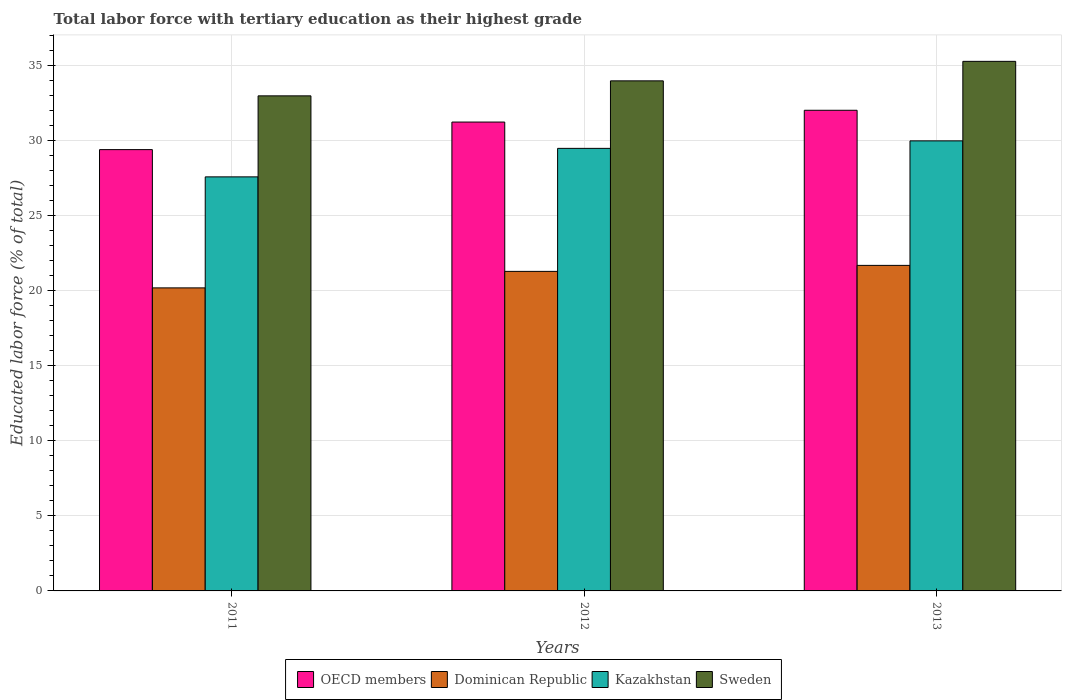Are the number of bars per tick equal to the number of legend labels?
Your answer should be compact. Yes. Are the number of bars on each tick of the X-axis equal?
Offer a very short reply. Yes. How many bars are there on the 2nd tick from the left?
Give a very brief answer. 4. What is the percentage of male labor force with tertiary education in Dominican Republic in 2011?
Offer a very short reply. 20.2. Across all years, what is the maximum percentage of male labor force with tertiary education in Kazakhstan?
Offer a terse response. 30. Across all years, what is the minimum percentage of male labor force with tertiary education in OECD members?
Keep it short and to the point. 29.42. What is the total percentage of male labor force with tertiary education in Dominican Republic in the graph?
Your response must be concise. 63.2. What is the difference between the percentage of male labor force with tertiary education in OECD members in 2011 and the percentage of male labor force with tertiary education in Sweden in 2013?
Your answer should be very brief. -5.88. What is the average percentage of male labor force with tertiary education in Kazakhstan per year?
Give a very brief answer. 29.03. In the year 2013, what is the difference between the percentage of male labor force with tertiary education in Kazakhstan and percentage of male labor force with tertiary education in OECD members?
Your response must be concise. -2.04. What is the ratio of the percentage of male labor force with tertiary education in Dominican Republic in 2012 to that in 2013?
Ensure brevity in your answer.  0.98. Is the percentage of male labor force with tertiary education in Dominican Republic in 2011 less than that in 2013?
Keep it short and to the point. Yes. What is the difference between the highest and the second highest percentage of male labor force with tertiary education in Dominican Republic?
Make the answer very short. 0.4. In how many years, is the percentage of male labor force with tertiary education in Dominican Republic greater than the average percentage of male labor force with tertiary education in Dominican Republic taken over all years?
Your answer should be compact. 2. Is it the case that in every year, the sum of the percentage of male labor force with tertiary education in OECD members and percentage of male labor force with tertiary education in Kazakhstan is greater than the sum of percentage of male labor force with tertiary education in Sweden and percentage of male labor force with tertiary education in Dominican Republic?
Give a very brief answer. No. What does the 4th bar from the left in 2011 represents?
Ensure brevity in your answer.  Sweden. Is it the case that in every year, the sum of the percentage of male labor force with tertiary education in Dominican Republic and percentage of male labor force with tertiary education in Sweden is greater than the percentage of male labor force with tertiary education in Kazakhstan?
Make the answer very short. Yes. How many years are there in the graph?
Offer a very short reply. 3. Where does the legend appear in the graph?
Ensure brevity in your answer.  Bottom center. How many legend labels are there?
Keep it short and to the point. 4. What is the title of the graph?
Make the answer very short. Total labor force with tertiary education as their highest grade. What is the label or title of the Y-axis?
Offer a terse response. Educated labor force (% of total). What is the Educated labor force (% of total) in OECD members in 2011?
Keep it short and to the point. 29.42. What is the Educated labor force (% of total) of Dominican Republic in 2011?
Your response must be concise. 20.2. What is the Educated labor force (% of total) of Kazakhstan in 2011?
Your answer should be very brief. 27.6. What is the Educated labor force (% of total) in OECD members in 2012?
Your response must be concise. 31.25. What is the Educated labor force (% of total) in Dominican Republic in 2012?
Provide a succinct answer. 21.3. What is the Educated labor force (% of total) of Kazakhstan in 2012?
Your response must be concise. 29.5. What is the Educated labor force (% of total) of Sweden in 2012?
Keep it short and to the point. 34. What is the Educated labor force (% of total) of OECD members in 2013?
Your answer should be compact. 32.04. What is the Educated labor force (% of total) in Dominican Republic in 2013?
Your answer should be very brief. 21.7. What is the Educated labor force (% of total) in Sweden in 2013?
Your answer should be compact. 35.3. Across all years, what is the maximum Educated labor force (% of total) of OECD members?
Keep it short and to the point. 32.04. Across all years, what is the maximum Educated labor force (% of total) of Dominican Republic?
Ensure brevity in your answer.  21.7. Across all years, what is the maximum Educated labor force (% of total) of Sweden?
Your answer should be very brief. 35.3. Across all years, what is the minimum Educated labor force (% of total) in OECD members?
Provide a short and direct response. 29.42. Across all years, what is the minimum Educated labor force (% of total) in Dominican Republic?
Offer a very short reply. 20.2. Across all years, what is the minimum Educated labor force (% of total) in Kazakhstan?
Offer a very short reply. 27.6. Across all years, what is the minimum Educated labor force (% of total) in Sweden?
Offer a terse response. 33. What is the total Educated labor force (% of total) of OECD members in the graph?
Your answer should be compact. 92.71. What is the total Educated labor force (% of total) of Dominican Republic in the graph?
Your answer should be compact. 63.2. What is the total Educated labor force (% of total) of Kazakhstan in the graph?
Keep it short and to the point. 87.1. What is the total Educated labor force (% of total) of Sweden in the graph?
Give a very brief answer. 102.3. What is the difference between the Educated labor force (% of total) of OECD members in 2011 and that in 2012?
Offer a very short reply. -1.84. What is the difference between the Educated labor force (% of total) of Sweden in 2011 and that in 2012?
Your response must be concise. -1. What is the difference between the Educated labor force (% of total) of OECD members in 2011 and that in 2013?
Provide a short and direct response. -2.62. What is the difference between the Educated labor force (% of total) of OECD members in 2012 and that in 2013?
Your response must be concise. -0.79. What is the difference between the Educated labor force (% of total) of Sweden in 2012 and that in 2013?
Ensure brevity in your answer.  -1.3. What is the difference between the Educated labor force (% of total) in OECD members in 2011 and the Educated labor force (% of total) in Dominican Republic in 2012?
Offer a terse response. 8.12. What is the difference between the Educated labor force (% of total) in OECD members in 2011 and the Educated labor force (% of total) in Kazakhstan in 2012?
Provide a succinct answer. -0.08. What is the difference between the Educated labor force (% of total) of OECD members in 2011 and the Educated labor force (% of total) of Sweden in 2012?
Your answer should be compact. -4.58. What is the difference between the Educated labor force (% of total) in OECD members in 2011 and the Educated labor force (% of total) in Dominican Republic in 2013?
Provide a short and direct response. 7.72. What is the difference between the Educated labor force (% of total) in OECD members in 2011 and the Educated labor force (% of total) in Kazakhstan in 2013?
Keep it short and to the point. -0.58. What is the difference between the Educated labor force (% of total) of OECD members in 2011 and the Educated labor force (% of total) of Sweden in 2013?
Provide a succinct answer. -5.88. What is the difference between the Educated labor force (% of total) of Dominican Republic in 2011 and the Educated labor force (% of total) of Sweden in 2013?
Make the answer very short. -15.1. What is the difference between the Educated labor force (% of total) in Kazakhstan in 2011 and the Educated labor force (% of total) in Sweden in 2013?
Your response must be concise. -7.7. What is the difference between the Educated labor force (% of total) of OECD members in 2012 and the Educated labor force (% of total) of Dominican Republic in 2013?
Provide a short and direct response. 9.55. What is the difference between the Educated labor force (% of total) in OECD members in 2012 and the Educated labor force (% of total) in Kazakhstan in 2013?
Give a very brief answer. 1.25. What is the difference between the Educated labor force (% of total) of OECD members in 2012 and the Educated labor force (% of total) of Sweden in 2013?
Your response must be concise. -4.05. What is the difference between the Educated labor force (% of total) of Dominican Republic in 2012 and the Educated labor force (% of total) of Sweden in 2013?
Give a very brief answer. -14. What is the average Educated labor force (% of total) of OECD members per year?
Offer a terse response. 30.9. What is the average Educated labor force (% of total) in Dominican Republic per year?
Your answer should be very brief. 21.07. What is the average Educated labor force (% of total) of Kazakhstan per year?
Your answer should be compact. 29.03. What is the average Educated labor force (% of total) in Sweden per year?
Provide a short and direct response. 34.1. In the year 2011, what is the difference between the Educated labor force (% of total) of OECD members and Educated labor force (% of total) of Dominican Republic?
Give a very brief answer. 9.22. In the year 2011, what is the difference between the Educated labor force (% of total) of OECD members and Educated labor force (% of total) of Kazakhstan?
Offer a terse response. 1.82. In the year 2011, what is the difference between the Educated labor force (% of total) of OECD members and Educated labor force (% of total) of Sweden?
Give a very brief answer. -3.58. In the year 2011, what is the difference between the Educated labor force (% of total) in Dominican Republic and Educated labor force (% of total) in Kazakhstan?
Make the answer very short. -7.4. In the year 2012, what is the difference between the Educated labor force (% of total) in OECD members and Educated labor force (% of total) in Dominican Republic?
Your answer should be very brief. 9.95. In the year 2012, what is the difference between the Educated labor force (% of total) of OECD members and Educated labor force (% of total) of Kazakhstan?
Keep it short and to the point. 1.75. In the year 2012, what is the difference between the Educated labor force (% of total) in OECD members and Educated labor force (% of total) in Sweden?
Ensure brevity in your answer.  -2.75. In the year 2012, what is the difference between the Educated labor force (% of total) in Dominican Republic and Educated labor force (% of total) in Kazakhstan?
Ensure brevity in your answer.  -8.2. In the year 2012, what is the difference between the Educated labor force (% of total) of Kazakhstan and Educated labor force (% of total) of Sweden?
Your answer should be compact. -4.5. In the year 2013, what is the difference between the Educated labor force (% of total) in OECD members and Educated labor force (% of total) in Dominican Republic?
Provide a short and direct response. 10.34. In the year 2013, what is the difference between the Educated labor force (% of total) in OECD members and Educated labor force (% of total) in Kazakhstan?
Offer a terse response. 2.04. In the year 2013, what is the difference between the Educated labor force (% of total) in OECD members and Educated labor force (% of total) in Sweden?
Your answer should be very brief. -3.26. What is the ratio of the Educated labor force (% of total) of Dominican Republic in 2011 to that in 2012?
Your answer should be very brief. 0.95. What is the ratio of the Educated labor force (% of total) in Kazakhstan in 2011 to that in 2012?
Keep it short and to the point. 0.94. What is the ratio of the Educated labor force (% of total) of Sweden in 2011 to that in 2012?
Offer a very short reply. 0.97. What is the ratio of the Educated labor force (% of total) of OECD members in 2011 to that in 2013?
Keep it short and to the point. 0.92. What is the ratio of the Educated labor force (% of total) in Dominican Republic in 2011 to that in 2013?
Make the answer very short. 0.93. What is the ratio of the Educated labor force (% of total) of Kazakhstan in 2011 to that in 2013?
Provide a succinct answer. 0.92. What is the ratio of the Educated labor force (% of total) in Sweden in 2011 to that in 2013?
Your answer should be very brief. 0.93. What is the ratio of the Educated labor force (% of total) of OECD members in 2012 to that in 2013?
Provide a succinct answer. 0.98. What is the ratio of the Educated labor force (% of total) of Dominican Republic in 2012 to that in 2013?
Give a very brief answer. 0.98. What is the ratio of the Educated labor force (% of total) of Kazakhstan in 2012 to that in 2013?
Make the answer very short. 0.98. What is the ratio of the Educated labor force (% of total) of Sweden in 2012 to that in 2013?
Keep it short and to the point. 0.96. What is the difference between the highest and the second highest Educated labor force (% of total) of OECD members?
Keep it short and to the point. 0.79. What is the difference between the highest and the second highest Educated labor force (% of total) of Dominican Republic?
Offer a very short reply. 0.4. What is the difference between the highest and the second highest Educated labor force (% of total) of Kazakhstan?
Provide a succinct answer. 0.5. What is the difference between the highest and the second highest Educated labor force (% of total) in Sweden?
Provide a short and direct response. 1.3. What is the difference between the highest and the lowest Educated labor force (% of total) in OECD members?
Keep it short and to the point. 2.62. What is the difference between the highest and the lowest Educated labor force (% of total) in Sweden?
Your answer should be compact. 2.3. 